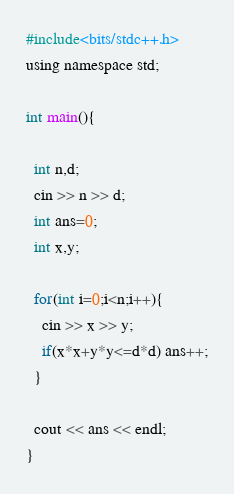<code> <loc_0><loc_0><loc_500><loc_500><_C_>#include<bits/stdc++.h>
using namespace std;

int main(){

  int n,d;
  cin >> n >> d;
  int ans=0;
  int x,y;

  for(int i=0;i<n;i++){
    cin >> x >> y;
    if(x*x+y*y<=d*d) ans++;
  }

  cout << ans << endl;
}
</code> 